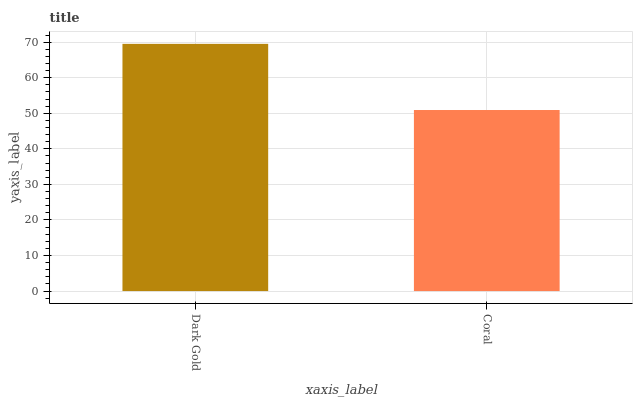Is Coral the minimum?
Answer yes or no. Yes. Is Dark Gold the maximum?
Answer yes or no. Yes. Is Coral the maximum?
Answer yes or no. No. Is Dark Gold greater than Coral?
Answer yes or no. Yes. Is Coral less than Dark Gold?
Answer yes or no. Yes. Is Coral greater than Dark Gold?
Answer yes or no. No. Is Dark Gold less than Coral?
Answer yes or no. No. Is Dark Gold the high median?
Answer yes or no. Yes. Is Coral the low median?
Answer yes or no. Yes. Is Coral the high median?
Answer yes or no. No. Is Dark Gold the low median?
Answer yes or no. No. 